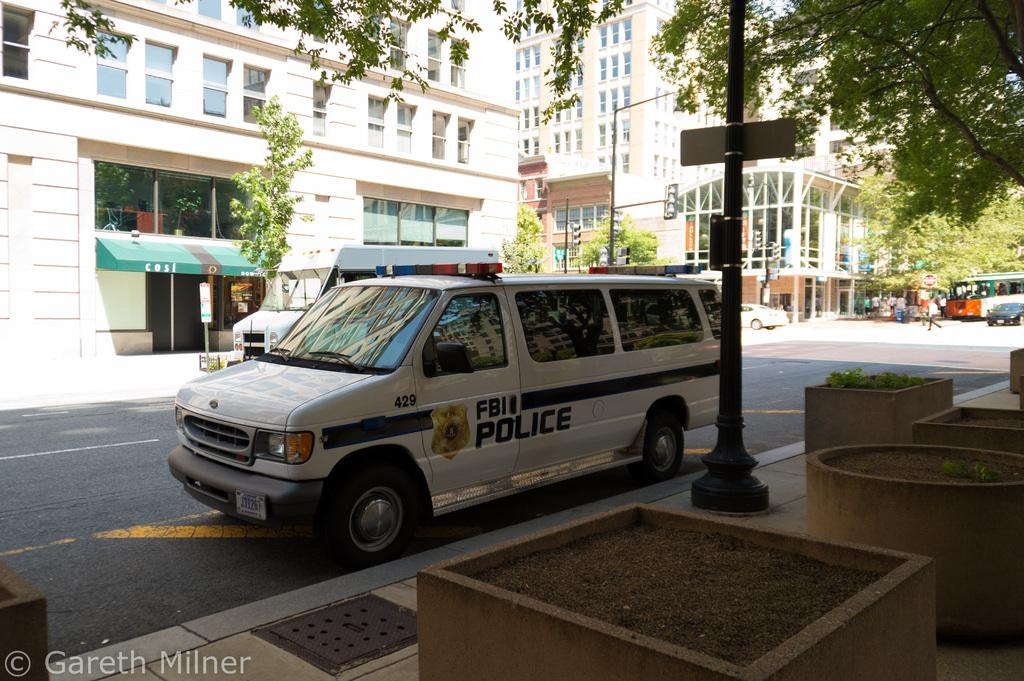What is parked on the road in the image? There is a car parked on the road in the image. What can be seen in the background of the image? There are trees and buildings in the backdrop of the image. What is the main feature of the foreground in the image? The main feature of the foreground in the image is the car parked on the road. What type of surface is visible in the image? There is a road visible in the image. Can you see a window in the car in the image? There is no window visible in the car in the image; it is a parked car, and the windows are not shown. 